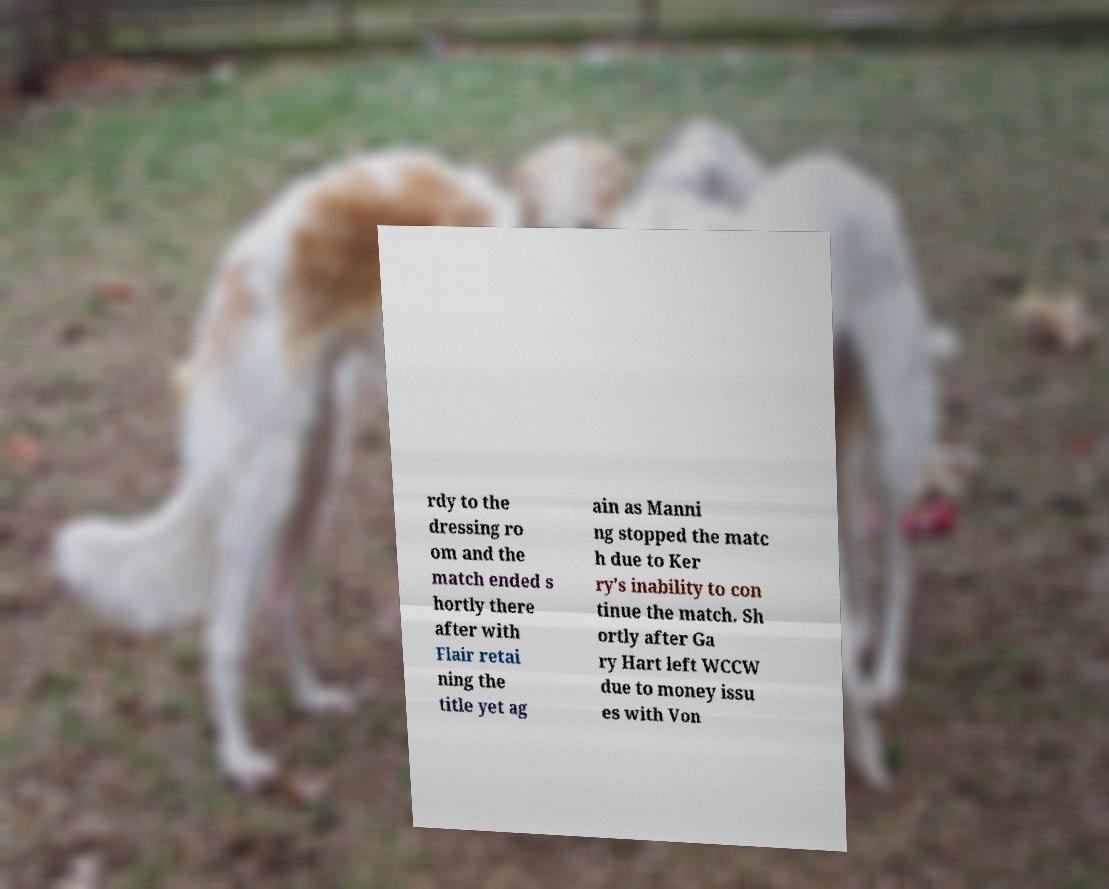There's text embedded in this image that I need extracted. Can you transcribe it verbatim? rdy to the dressing ro om and the match ended s hortly there after with Flair retai ning the title yet ag ain as Manni ng stopped the matc h due to Ker ry's inability to con tinue the match. Sh ortly after Ga ry Hart left WCCW due to money issu es with Von 